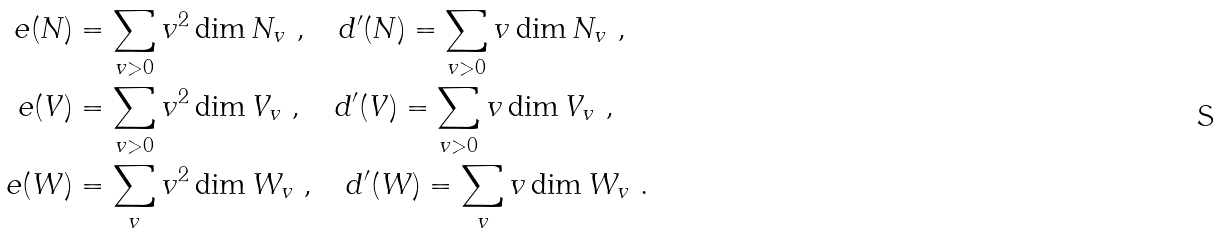Convert formula to latex. <formula><loc_0><loc_0><loc_500><loc_500>e ( N ) & = \sum _ { v > 0 } v ^ { 2 } \dim N _ { v } \ , \quad d ^ { \prime } ( N ) = \sum _ { v > 0 } v \dim N _ { v } \ , \\ e ( V ) & = \sum _ { v > 0 } v ^ { 2 } \dim V _ { v } \ , \quad d ^ { \prime } ( V ) = \sum _ { v > 0 } v \dim V _ { v } \ , \\ e ( W ) & = \sum _ { v } v ^ { 2 } \dim W _ { v } \ , \quad d ^ { \prime } ( W ) = \sum _ { v } v \dim W _ { v } \ .</formula> 